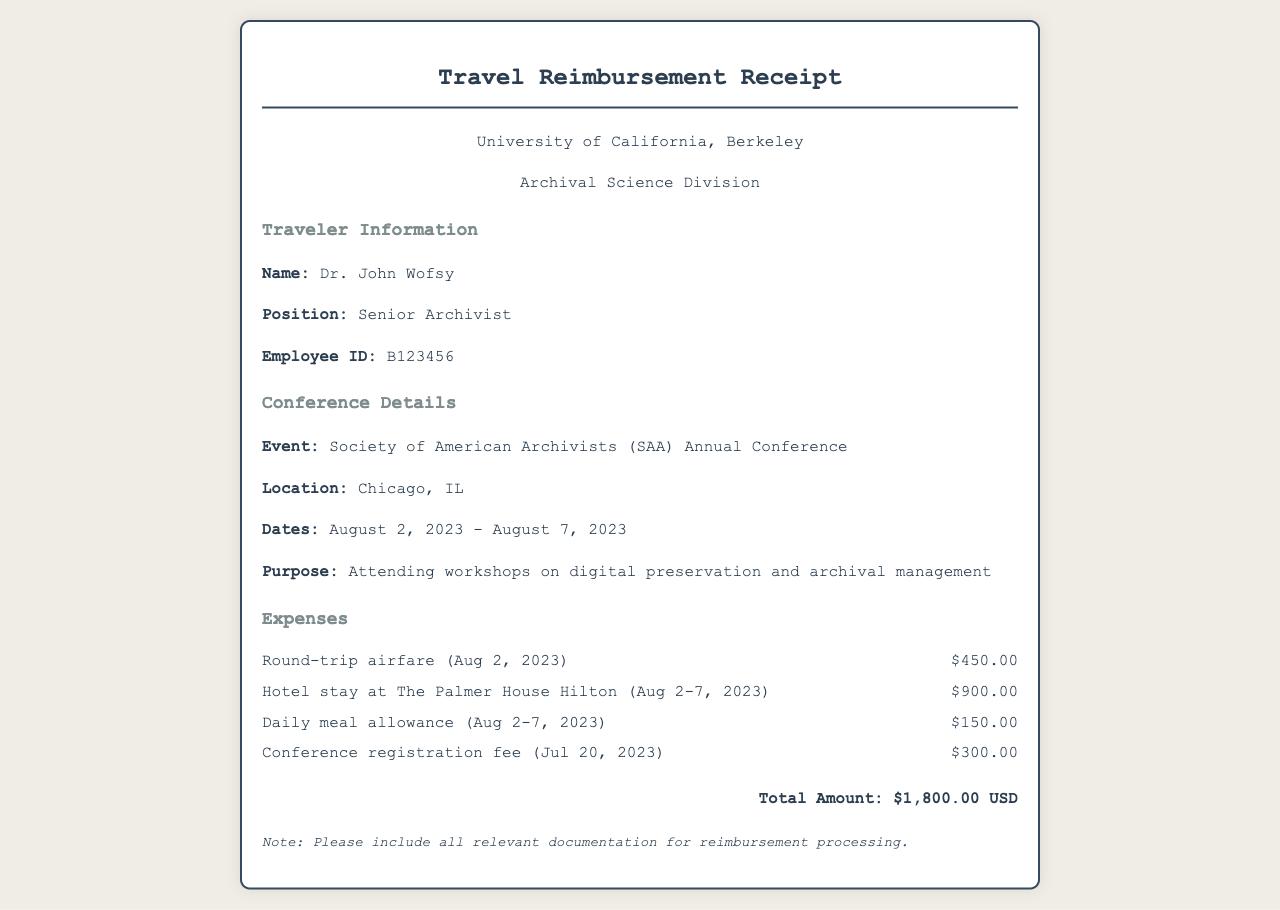What is the total amount of expenses claimed? The total amount is listed at the bottom of the receipt and includes all expenses incurred during the trip.
Answer: $1,800.00 USD Who is the traveler mentioned in the document? The document specifies the name of the traveler in the "Traveler Information" section.
Answer: Dr. John Wofsy What is the purpose of the travel? The purpose can be found in the "Conference Details" section, indicating the reason for attending the conference.
Answer: Attending workshops on digital preservation and archival management When did the conference take place? The dates of the conference are provided in the "Conference Details" section of the receipt.
Answer: August 2, 2023 - August 7, 2023 What was the location of the conference? The location is specified in the "Conference Details" section, indicating where the event took place.
Answer: Chicago, IL How much was the hotel stay? The amount for the hotel stay is provided in the "Expenses" section, detailing the cost incurred for accommodation.
Answer: $900.00 What type of document is this? The document serves a specific function and provides information related to travel and expenses.
Answer: Travel Reimbursement Receipt What was the registration fee date? The date for the conference registration fee is mentioned in the "Expenses" section.
Answer: July 20, 2023 